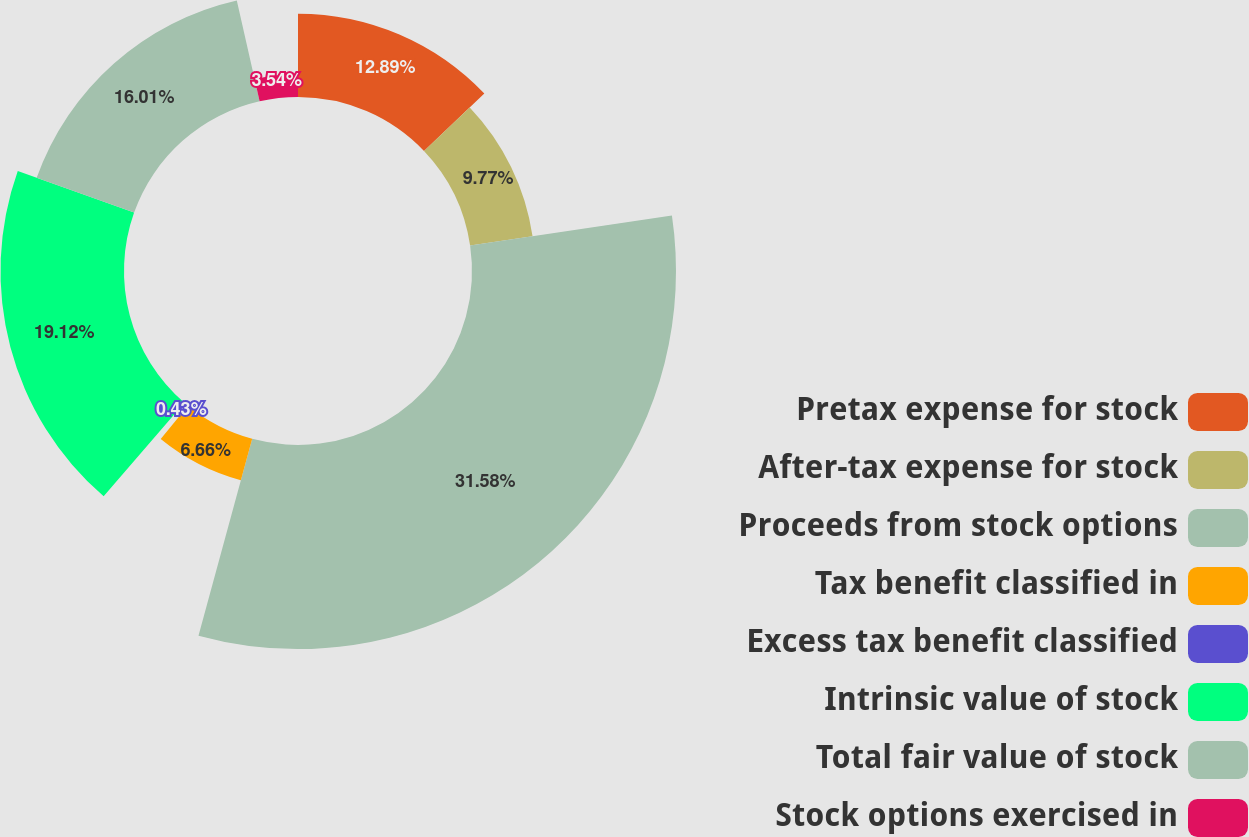Convert chart. <chart><loc_0><loc_0><loc_500><loc_500><pie_chart><fcel>Pretax expense for stock<fcel>After-tax expense for stock<fcel>Proceeds from stock options<fcel>Tax benefit classified in<fcel>Excess tax benefit classified<fcel>Intrinsic value of stock<fcel>Total fair value of stock<fcel>Stock options exercised in<nl><fcel>12.89%<fcel>9.77%<fcel>31.58%<fcel>6.66%<fcel>0.43%<fcel>19.12%<fcel>16.01%<fcel>3.54%<nl></chart> 